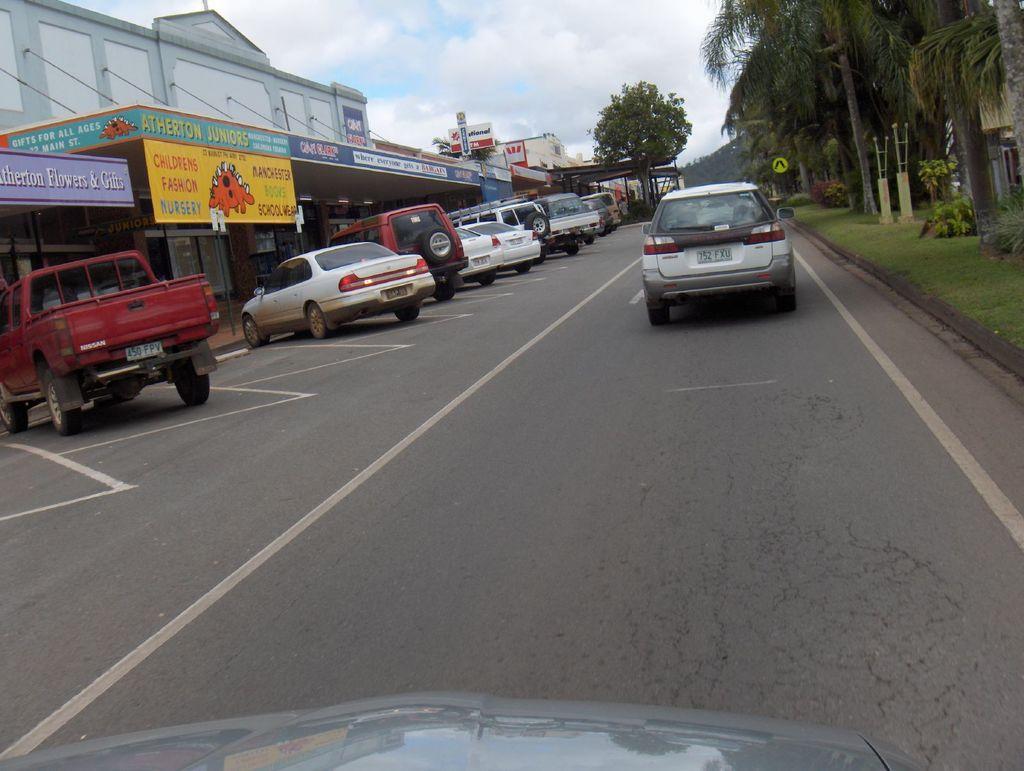Could you give a brief overview of what you see in this image? As we can see in the image there are cars, truck, banner, buildings, trees and grass. On the top there is sky. 